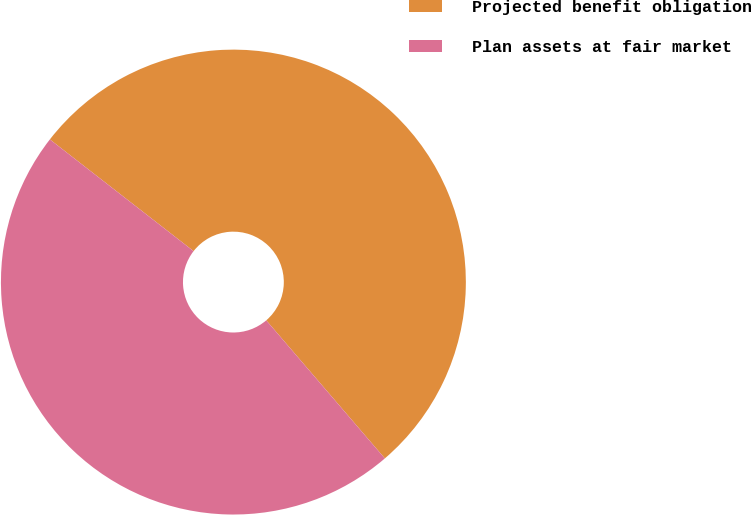Convert chart to OTSL. <chart><loc_0><loc_0><loc_500><loc_500><pie_chart><fcel>Projected benefit obligation<fcel>Plan assets at fair market<nl><fcel>53.19%<fcel>46.81%<nl></chart> 